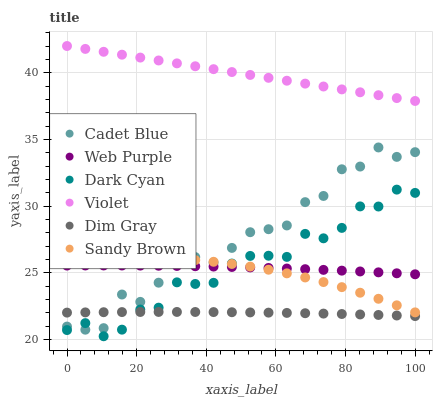Does Dim Gray have the minimum area under the curve?
Answer yes or no. Yes. Does Violet have the maximum area under the curve?
Answer yes or no. Yes. Does Web Purple have the minimum area under the curve?
Answer yes or no. No. Does Web Purple have the maximum area under the curve?
Answer yes or no. No. Is Violet the smoothest?
Answer yes or no. Yes. Is Cadet Blue the roughest?
Answer yes or no. Yes. Is Web Purple the smoothest?
Answer yes or no. No. Is Web Purple the roughest?
Answer yes or no. No. Does Dark Cyan have the lowest value?
Answer yes or no. Yes. Does Web Purple have the lowest value?
Answer yes or no. No. Does Violet have the highest value?
Answer yes or no. Yes. Does Web Purple have the highest value?
Answer yes or no. No. Is Dim Gray less than Sandy Brown?
Answer yes or no. Yes. Is Violet greater than Cadet Blue?
Answer yes or no. Yes. Does Web Purple intersect Sandy Brown?
Answer yes or no. Yes. Is Web Purple less than Sandy Brown?
Answer yes or no. No. Is Web Purple greater than Sandy Brown?
Answer yes or no. No. Does Dim Gray intersect Sandy Brown?
Answer yes or no. No. 